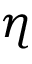<formula> <loc_0><loc_0><loc_500><loc_500>\eta</formula> 